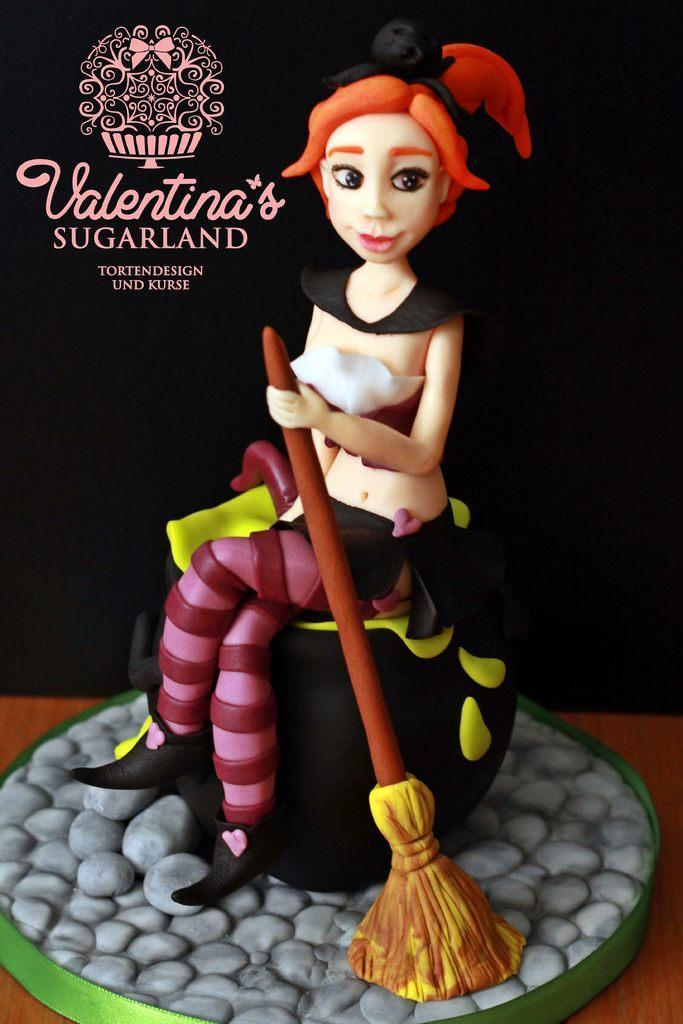Please provide a concise description of this image. This is a poster and in this poster we can see a doll on the surface, some text and in the background it is dark. 